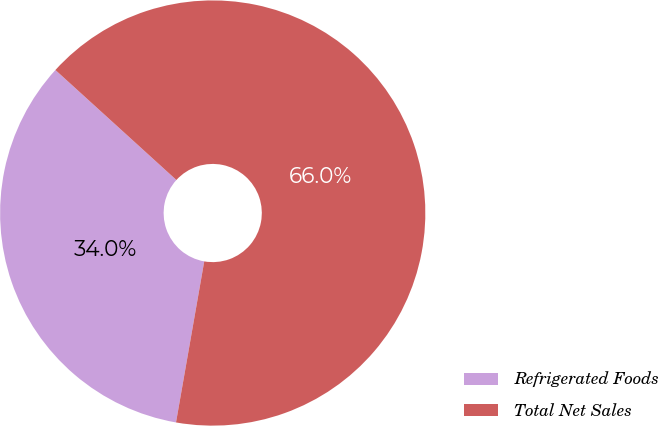<chart> <loc_0><loc_0><loc_500><loc_500><pie_chart><fcel>Refrigerated Foods<fcel>Total Net Sales<nl><fcel>33.98%<fcel>66.02%<nl></chart> 